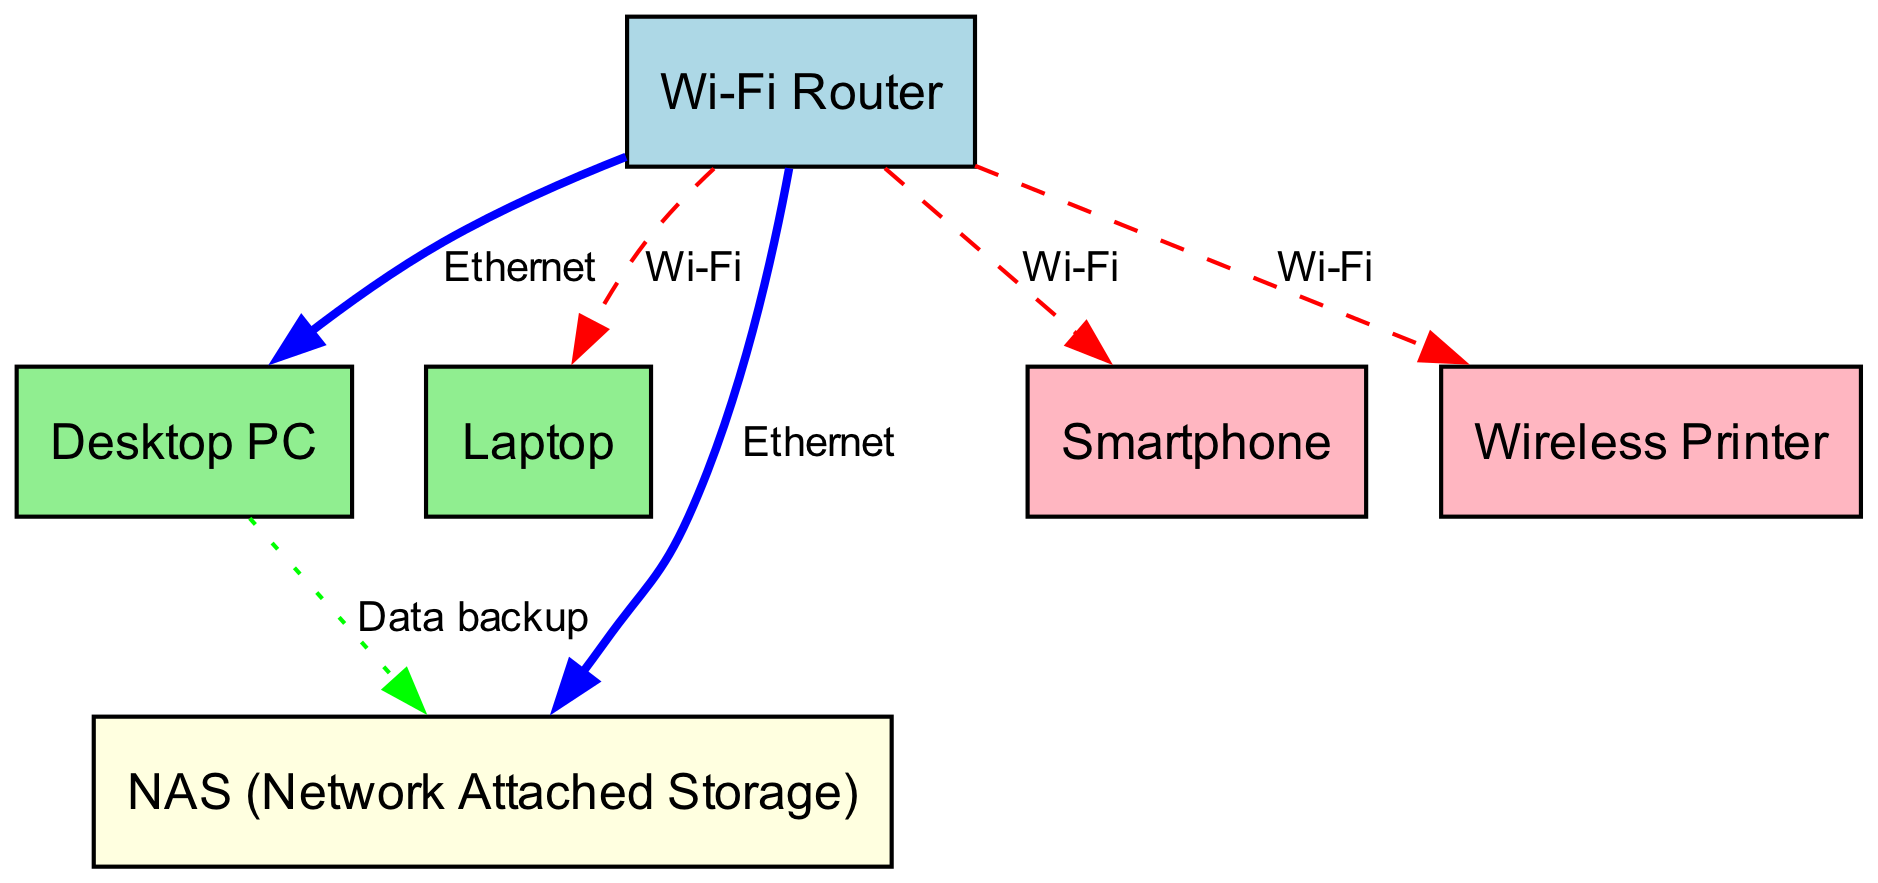What is the total number of devices shown in the diagram? The diagram lists six nodes, each representing a different device: Wi-Fi Router, Desktop PC, Laptop, NAS, Smartphone, and Wireless Printer. Therefore, the total number of devices is simply the count of these nodes.
Answer: 6 What type of connection does the router use to connect to the desktop PC? The connection between the router and the desktop PC is labeled as "Ethernet" in the diagram. This suggests a wired connection, contrasting with other connections that might be wireless.
Answer: Ethernet Which devices are connected to the router via Wi-Fi? The devices connected to the router via Wi-Fi, as represented in the diagram, are the Laptop, Smartphone, and Wireless Printer. This can be inferred from the dashed lines labeled "Wi-Fi" coming out from the router.
Answer: Laptop, Smartphone, Wireless Printer How many devices are directly connected to the NAS? The NAS has two direct connections in the diagram: one to the router (via Ethernet) and one to the desktop PC (for data backup). Since the question asks for the number of devices, we consider only the desktop and the router as direct connections.
Answer: 2 What kind of connection is established between the desktop and the NAS? The diagram indicates that the connection between the desktop and the NAS is labeled as "Data backup." This suggests that this link is for the purpose of backing up data, highlighting a specific function of the connection.
Answer: Data backup Which devices connect to the router using Ethernet connections? The devices that connect to the router using Ethernet are mentioned explicitly in the diagram: Desktop PC and NAS. This can be ascertained from the edges labeled as "Ethernet," indicating wired connections.
Answer: Desktop PC, NAS What type of devices are connected to the router besides the Laptop? Besides the Laptop, the devices connected to the router are the Desktop PC, NAS, Smartphone, and Wireless Printer. These devices are the ones identified in the node list, and they are all directly linked to the router.
Answer: Desktop PC, NAS, Smartphone, Wireless Printer How many types of connections are represented in the diagram? The diagram shows two distinct types of connections: Ethernet and Wi-Fi. The Ethernet connections are shown with solid lines, while the Wi-Fi connections are represented with dashed lines. This differentiation emphasizes the nature of the connections in the network setup.
Answer: 2 